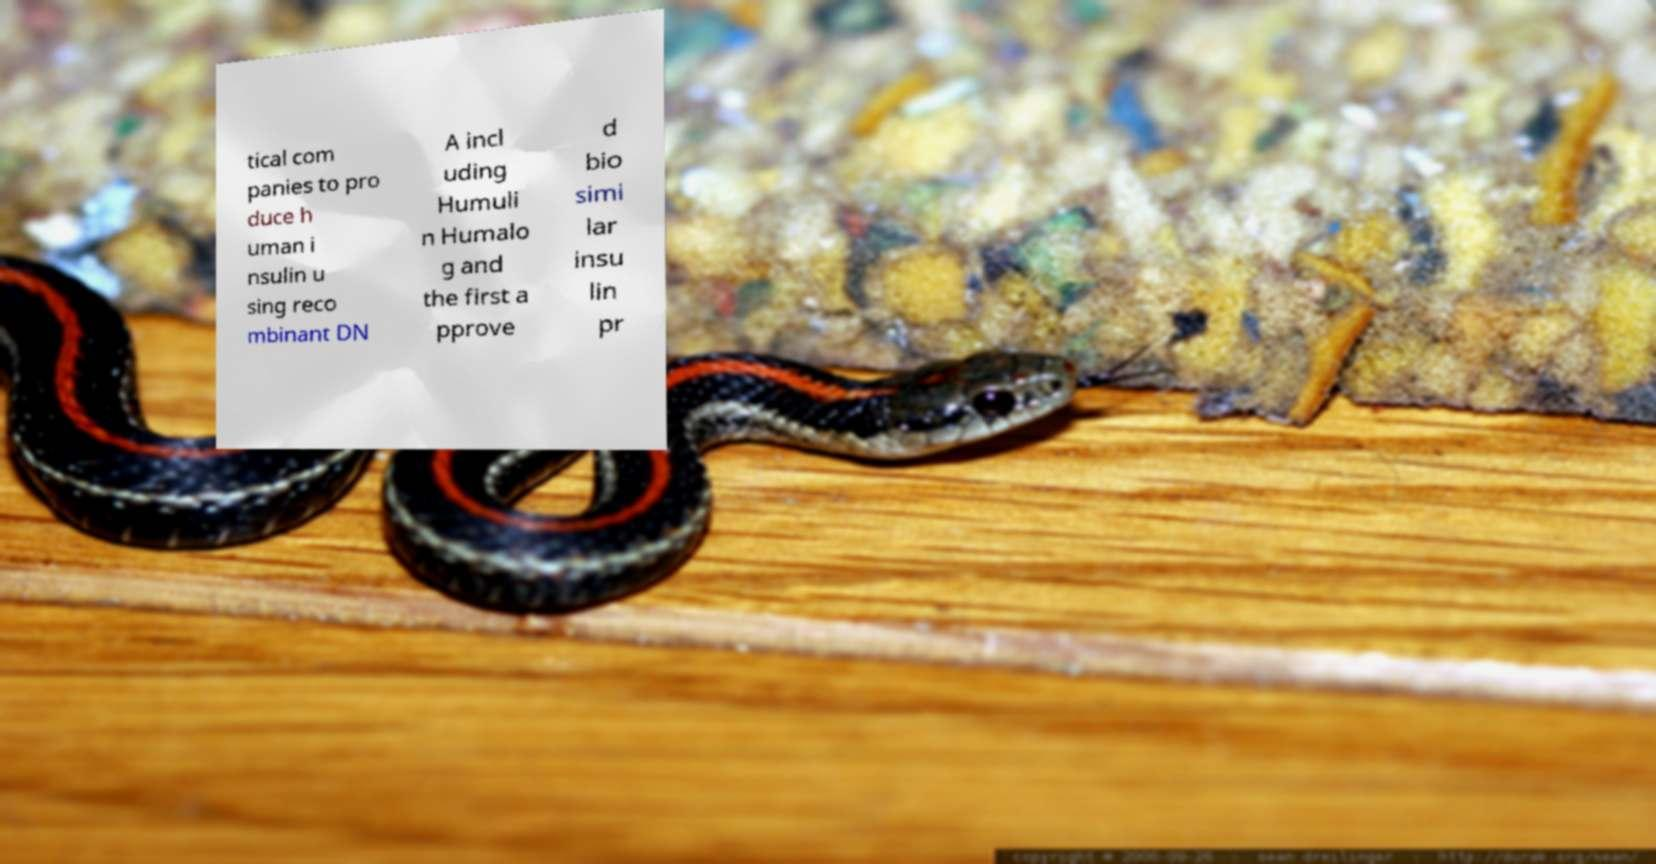Could you assist in decoding the text presented in this image and type it out clearly? tical com panies to pro duce h uman i nsulin u sing reco mbinant DN A incl uding Humuli n Humalo g and the first a pprove d bio simi lar insu lin pr 